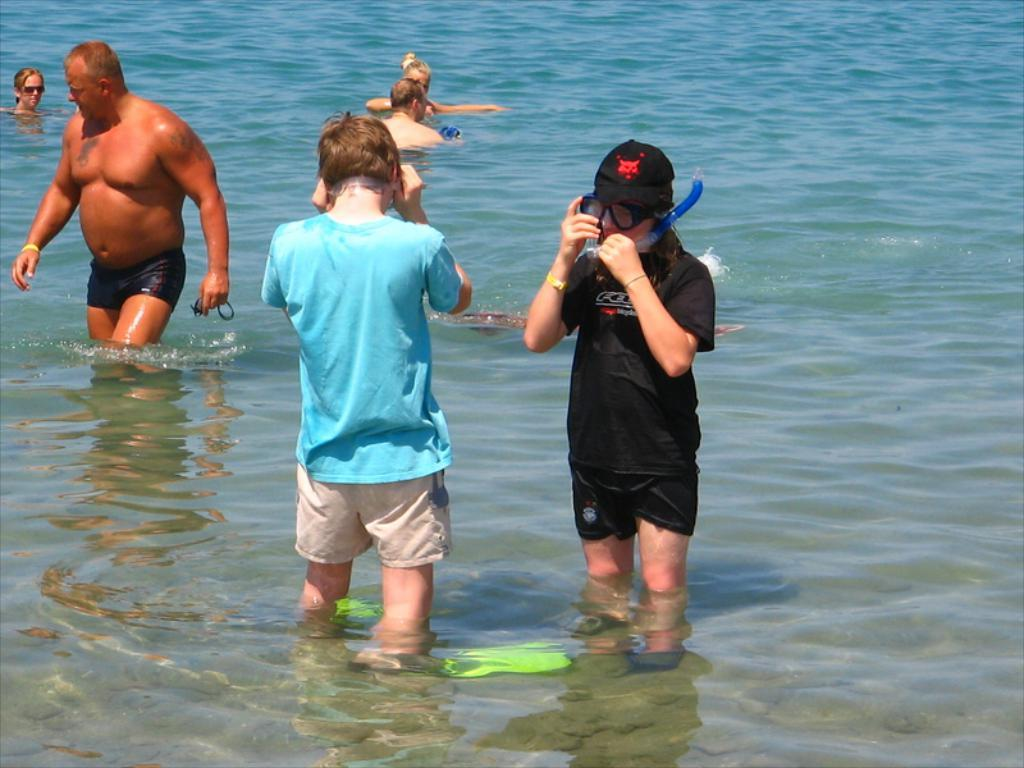How many people are in the image? There are a few people in the image. What are the people doing in the image? The people are standing in the water. What type of watch is the aunt wearing in the image? There is no aunt or watch present in the image. What type of rest area can be seen in the image? There is no rest area present in the image; it features people standing in the water. 